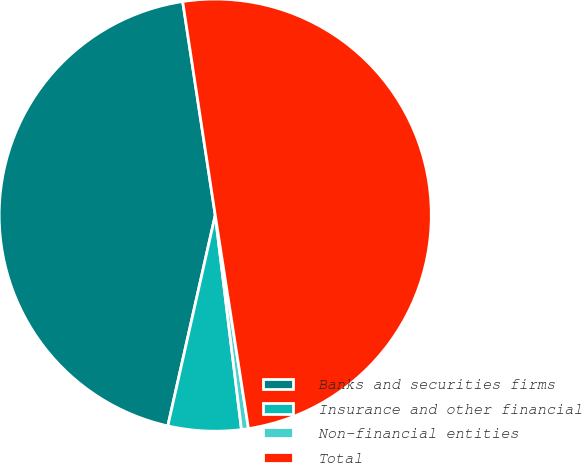Convert chart to OTSL. <chart><loc_0><loc_0><loc_500><loc_500><pie_chart><fcel>Banks and securities firms<fcel>Insurance and other financial<fcel>Non-financial entities<fcel>Total<nl><fcel>44.07%<fcel>5.46%<fcel>0.52%<fcel>49.95%<nl></chart> 